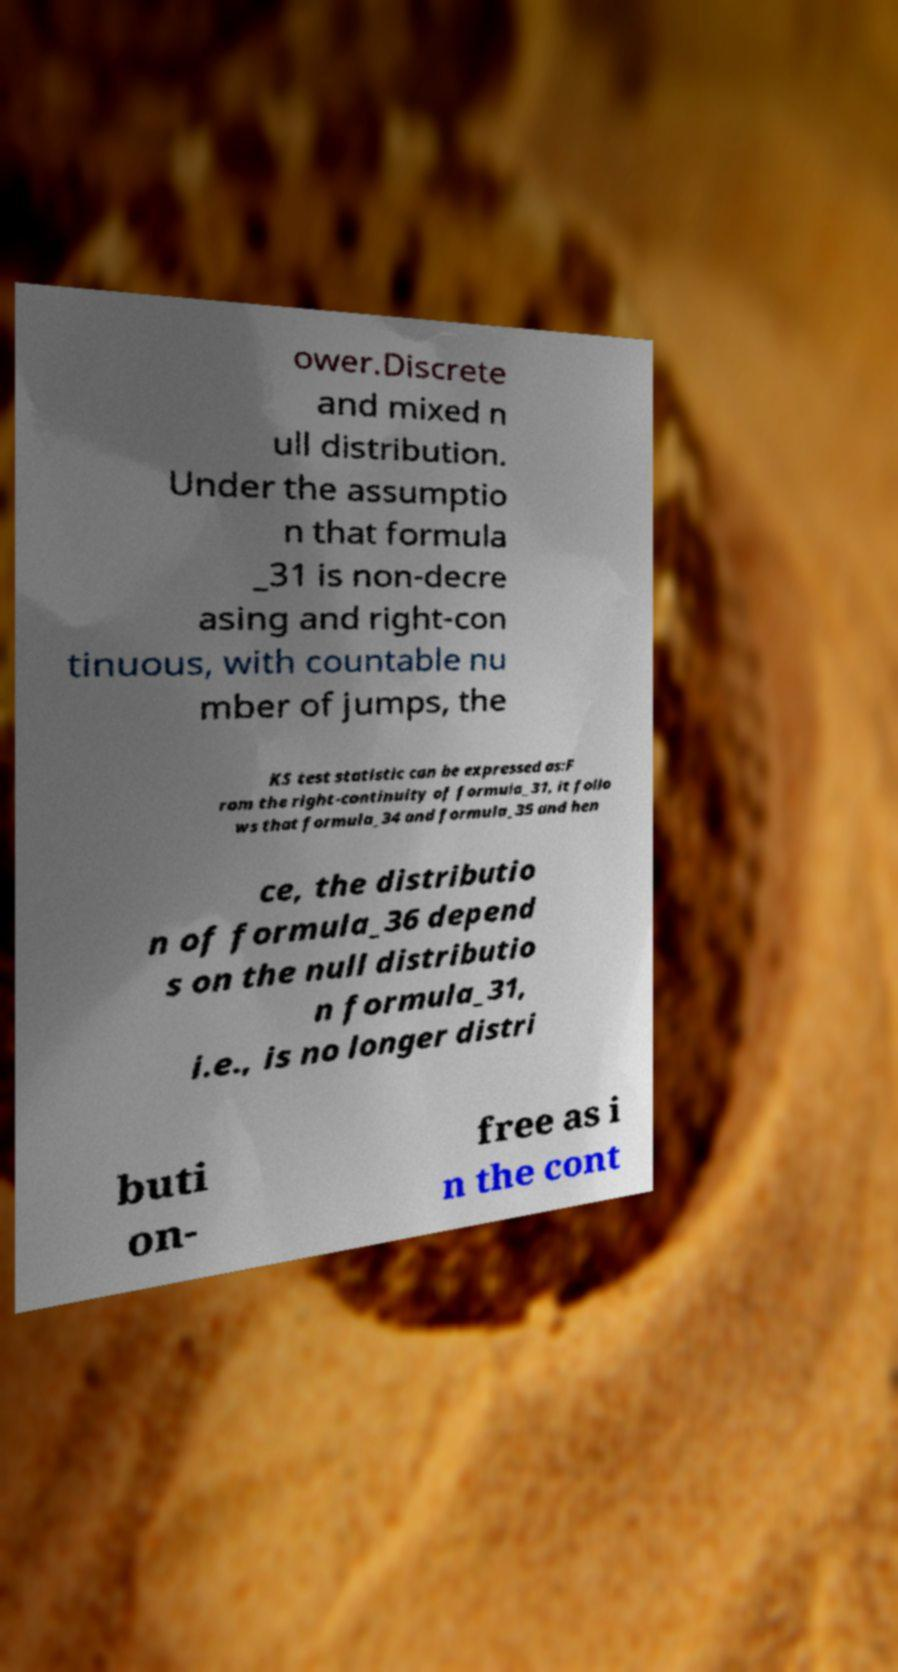I need the written content from this picture converted into text. Can you do that? ower.Discrete and mixed n ull distribution. Under the assumptio n that formula _31 is non-decre asing and right-con tinuous, with countable nu mber of jumps, the KS test statistic can be expressed as:F rom the right-continuity of formula_31, it follo ws that formula_34 and formula_35 and hen ce, the distributio n of formula_36 depend s on the null distributio n formula_31, i.e., is no longer distri buti on- free as i n the cont 